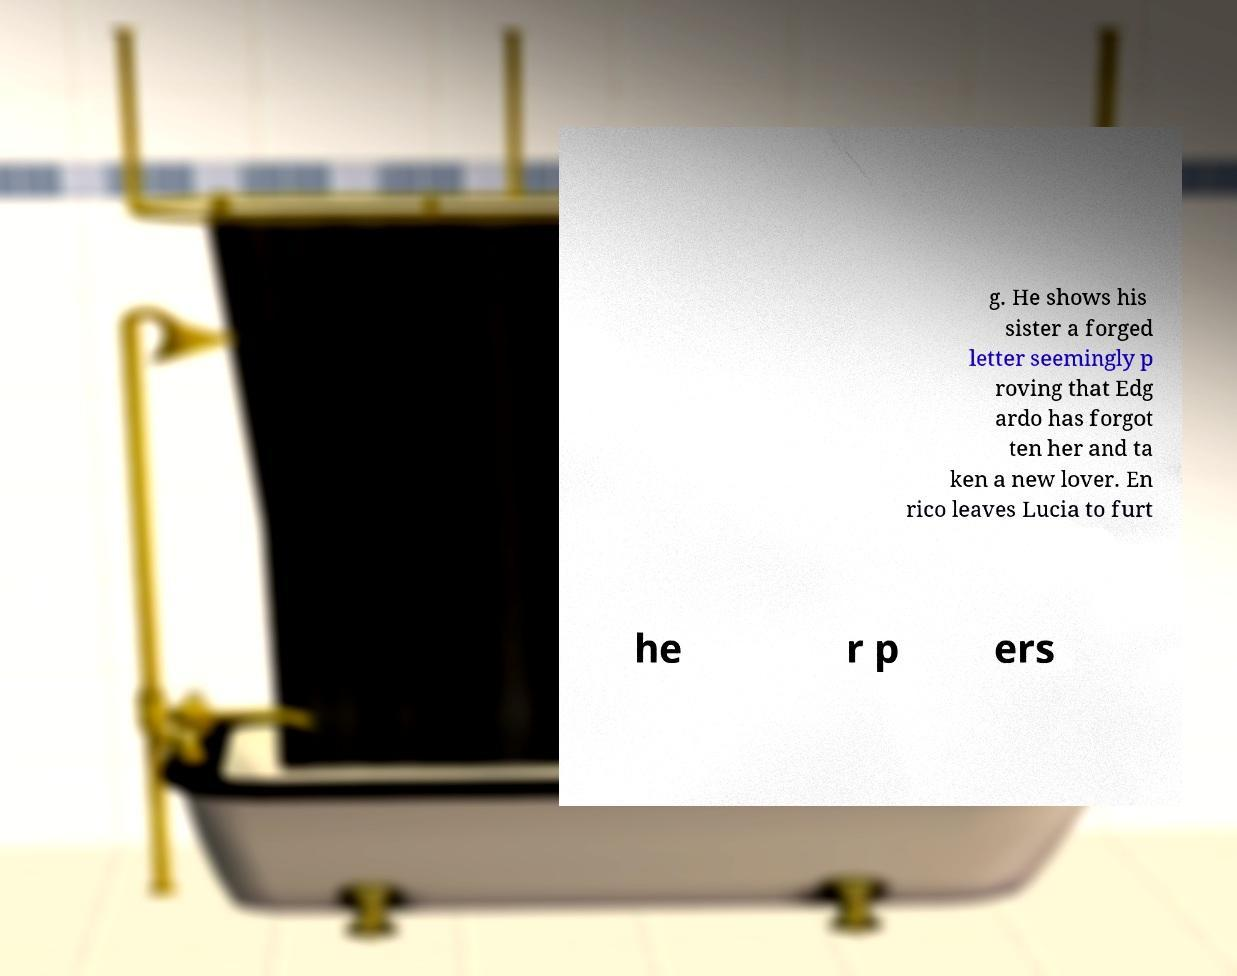Please identify and transcribe the text found in this image. g. He shows his sister a forged letter seemingly p roving that Edg ardo has forgot ten her and ta ken a new lover. En rico leaves Lucia to furt he r p ers 